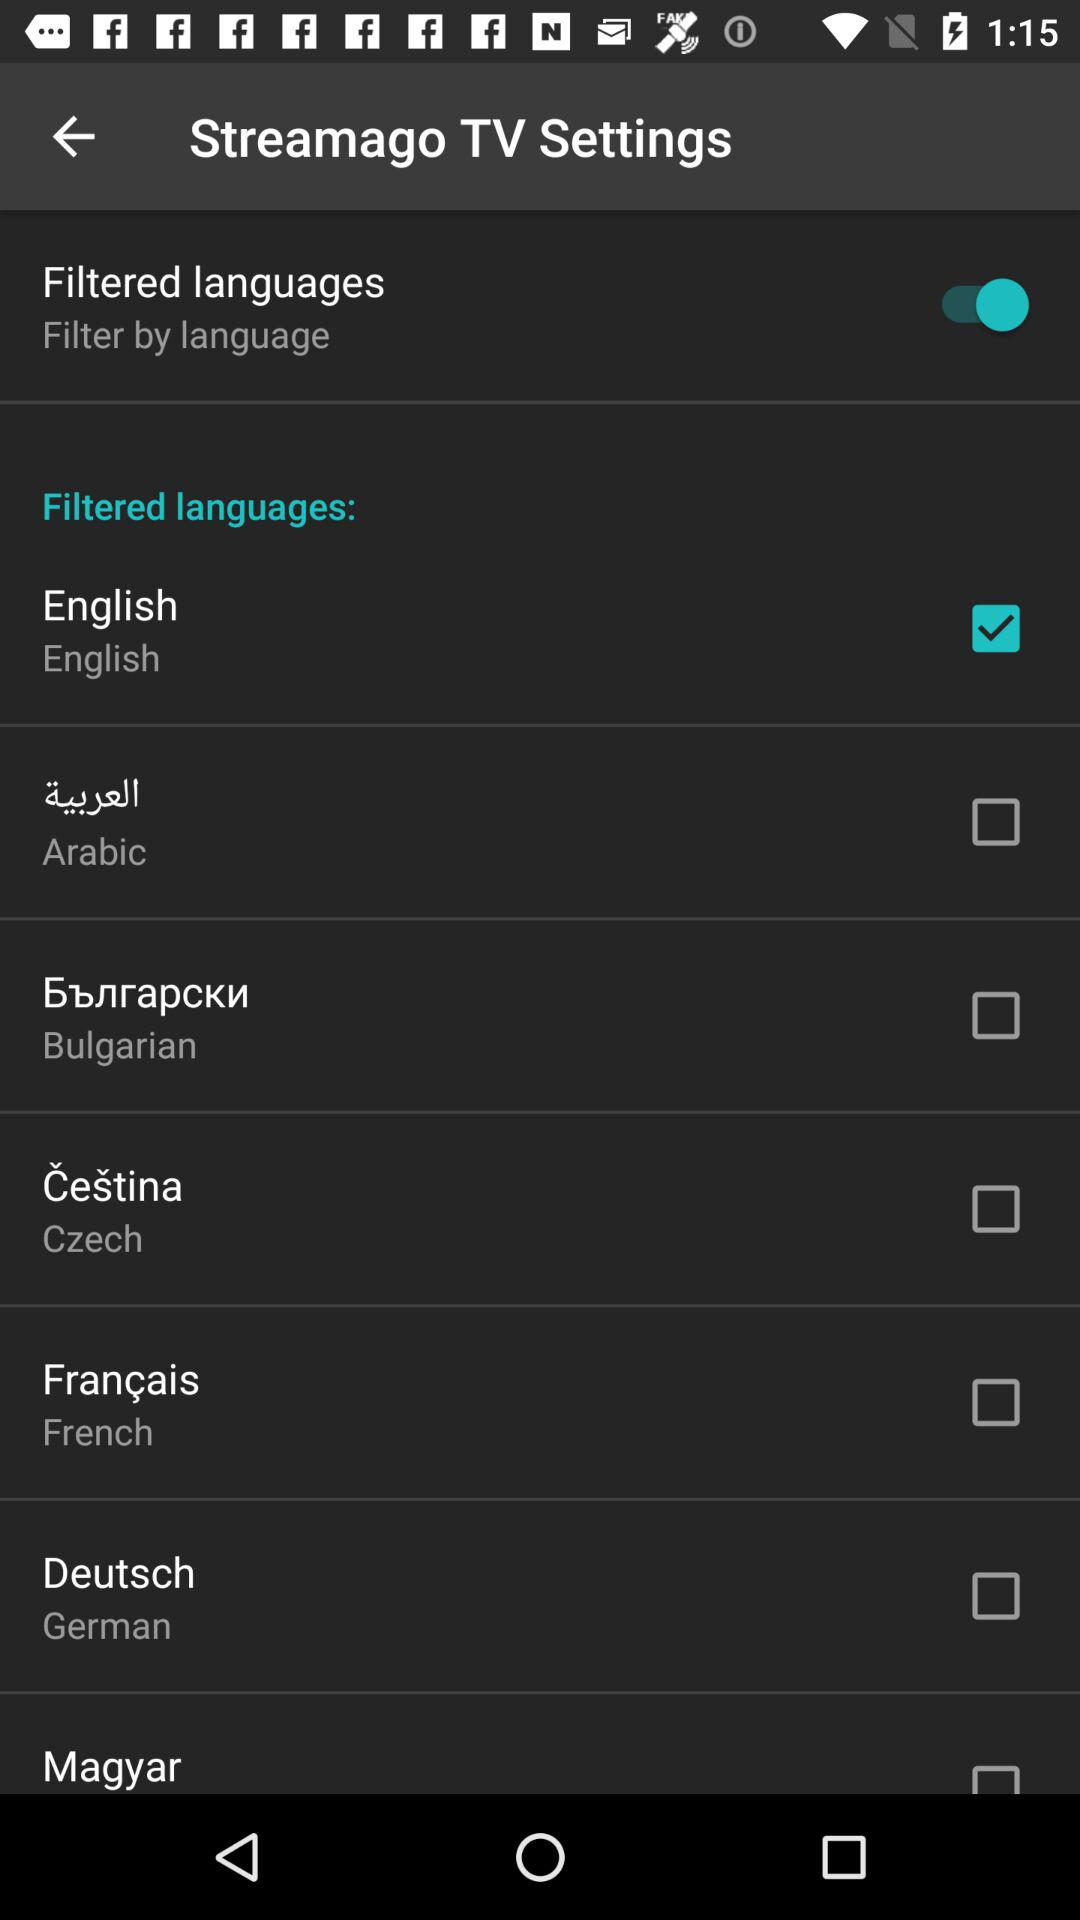Which language is selected? The selected language is English. 